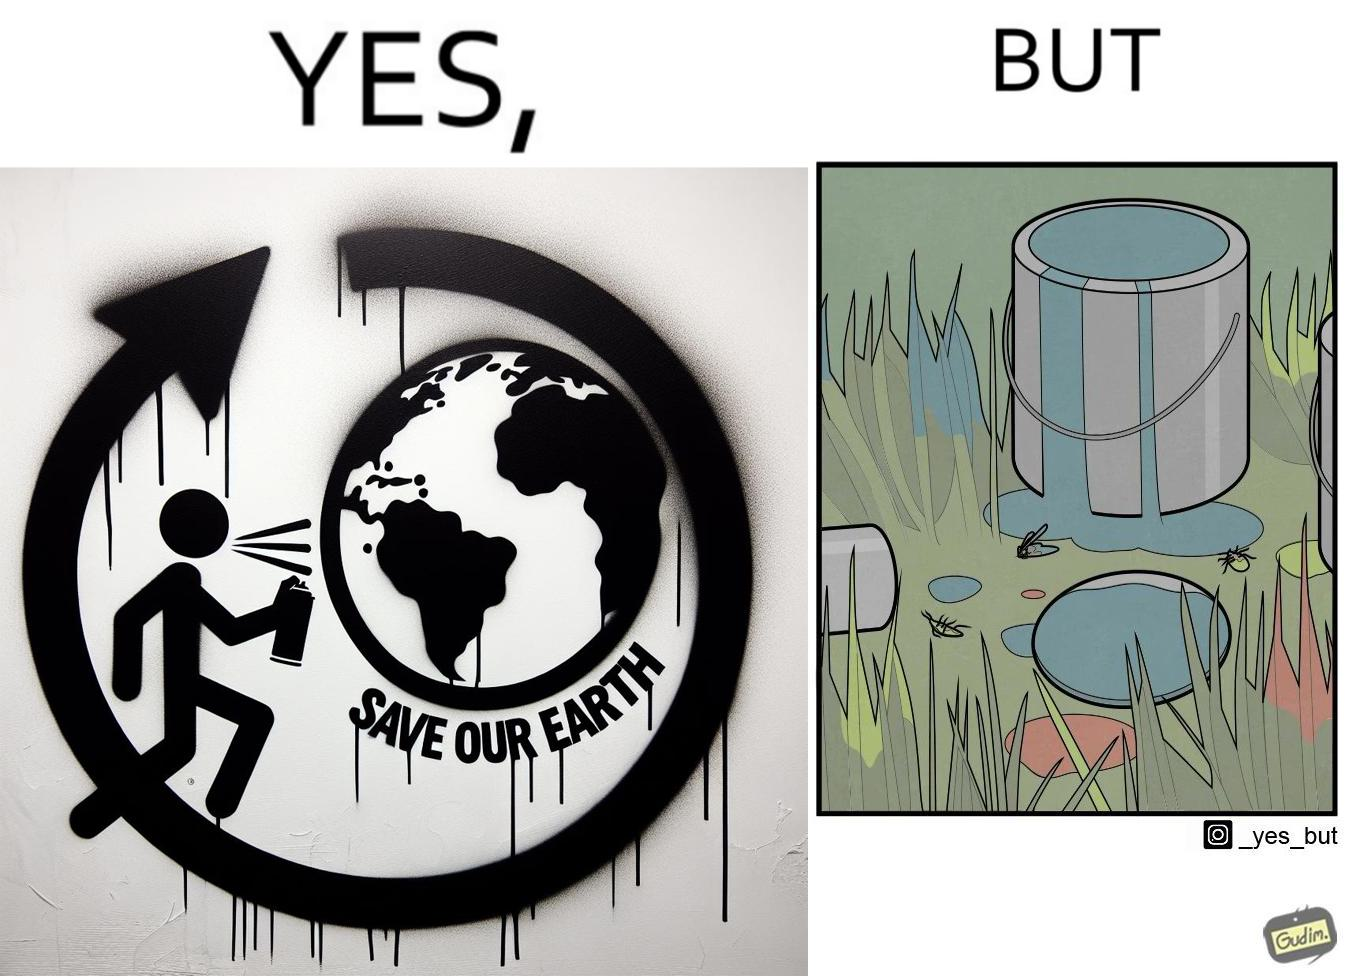Describe what you see in this image. The image is ironical, as the cans of paint used to make graffiti on the theme "Save the Earth" seems to be destroying the Earth when it overflows on the grass, as it is harmful for the flora and fauna, as can be seen from the dying insects. 